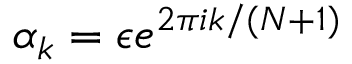<formula> <loc_0><loc_0><loc_500><loc_500>\alpha _ { k } = \epsilon e ^ { 2 \pi i k / ( N + 1 ) }</formula> 